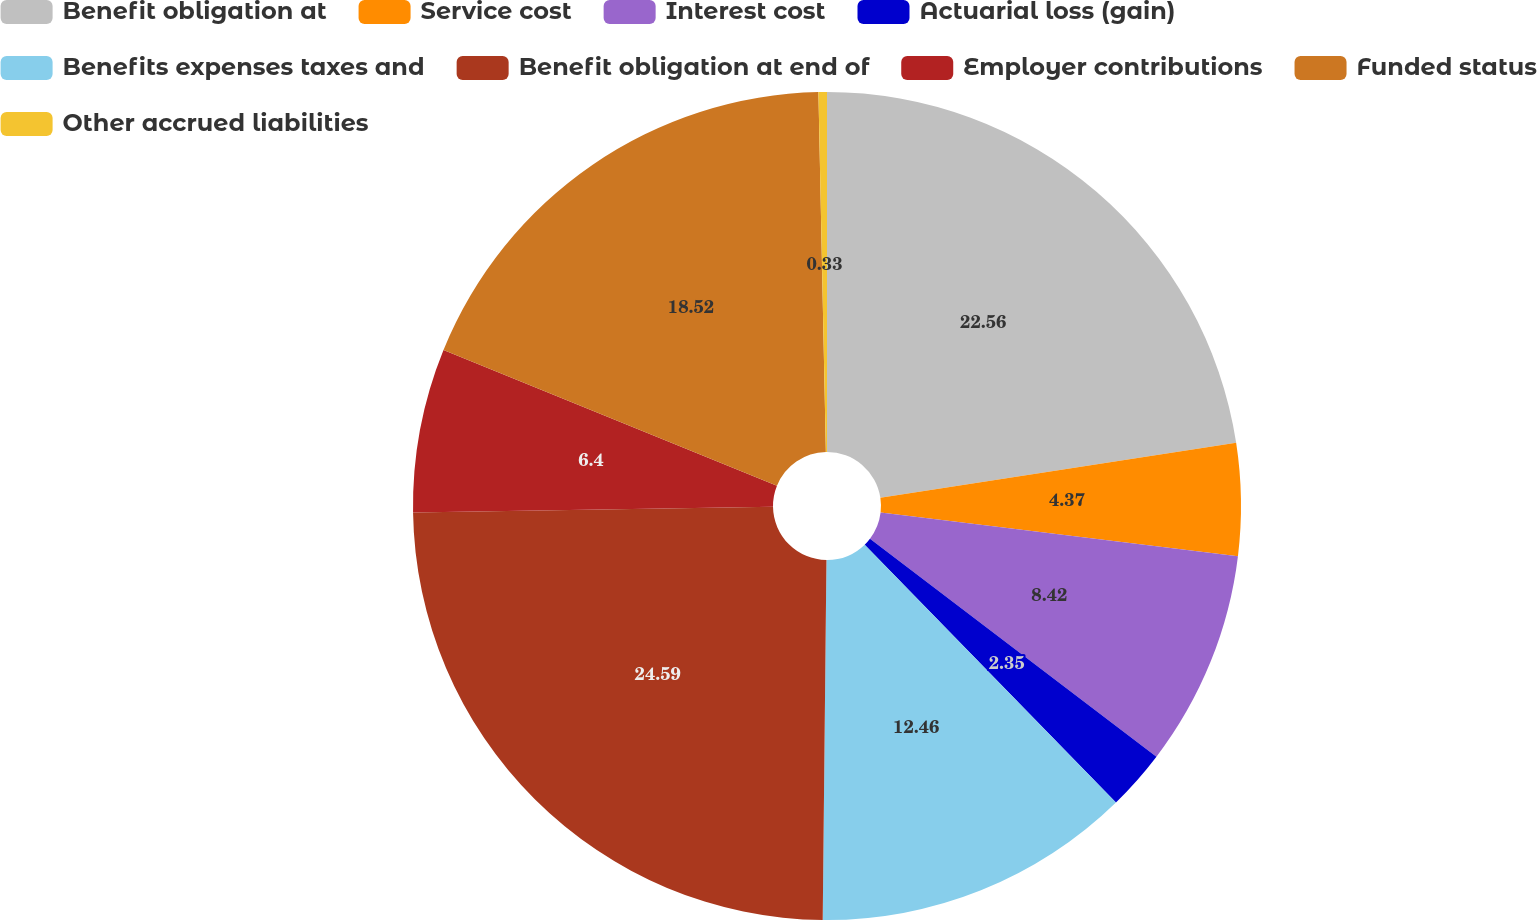<chart> <loc_0><loc_0><loc_500><loc_500><pie_chart><fcel>Benefit obligation at<fcel>Service cost<fcel>Interest cost<fcel>Actuarial loss (gain)<fcel>Benefits expenses taxes and<fcel>Benefit obligation at end of<fcel>Employer contributions<fcel>Funded status<fcel>Other accrued liabilities<nl><fcel>22.56%<fcel>4.37%<fcel>8.42%<fcel>2.35%<fcel>12.46%<fcel>24.58%<fcel>6.4%<fcel>18.52%<fcel>0.33%<nl></chart> 